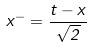<formula> <loc_0><loc_0><loc_500><loc_500>x ^ { - } = \frac { t - x } { \sqrt { 2 } }</formula> 